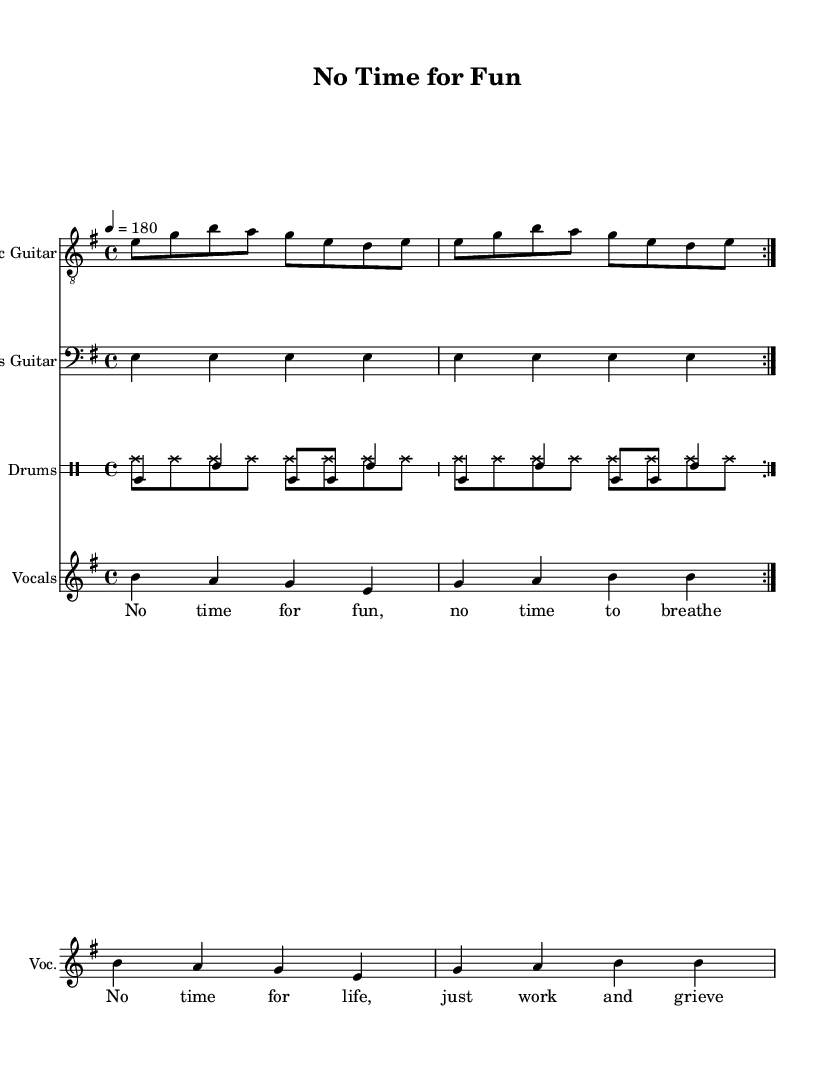What is the key signature of this music? The key signature is E minor; it indicates that there is one sharp (F#) and is typically represented at the beginning of the staff.
Answer: E minor What is the time signature of this music? The time signature is 4/4, which is indicated at the beginning of the sheet music. It means there are four beats in each measure, and the quarter note gets one beat.
Answer: 4/4 What is the tempo marking for this music? The tempo marking is 4 = 180, which indicates the tempo is 180 beats per minute, meaning the quarter note is the beat unit.
Answer: 180 How many measures are repeated in the electric guitar part? The electric guitar part has a repeated section; this is indicated by the "volta" marking shown at the end of the repeated section, which indicates to play it twice.
Answer: 2 What is the primary theme expressed in the chorus lyrics? The chorus lyrics emphasize a feeling of being overwhelmed and lacking time for enjoyment, reflecting the struggles of workaholics. This is a central theme of the song.
Answer: Workaholic struggles How many instruments are included in this score? There are four instruments represented in this score: Electric Guitar, Bass Guitar, Drums, and Vocals, as seen in the staff headers.
Answer: 4 What is the overall mood conveyed by this punk song? The overall mood conveyed by the song is satirical and critical; it comments on the inability of workaholics to relax, often characterized by a fast-paced rhythm typical of punk music.
Answer: Satirical and critical 